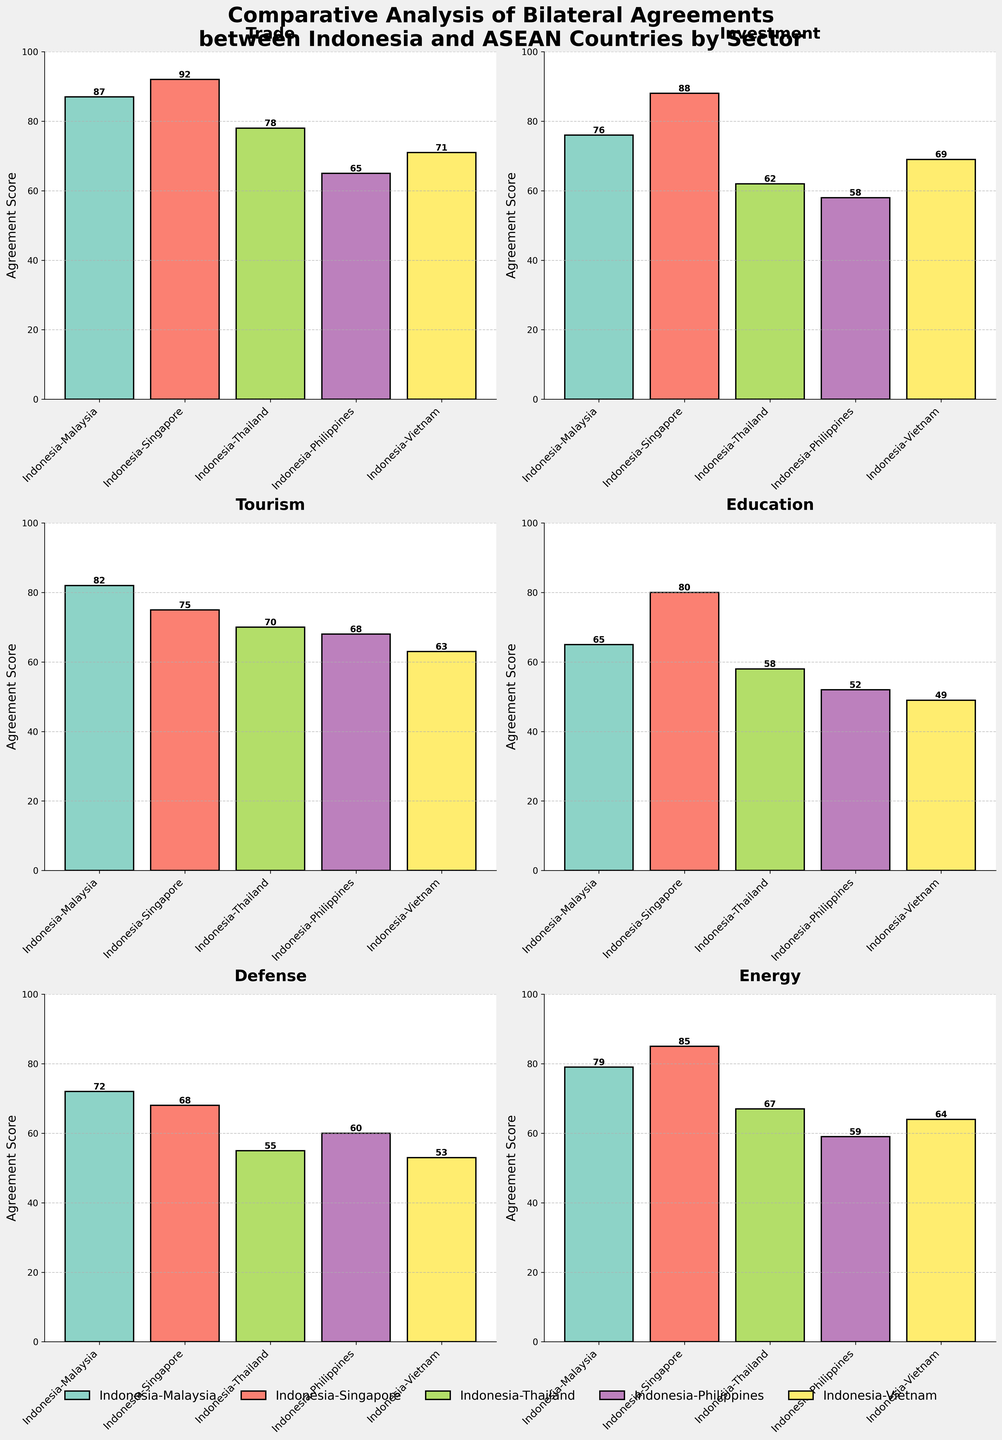Which sector has the highest agreement score between Indonesia and Vietnam? By examining the heights of the bars corresponding to Indonesia-Vietnam in each subplot, the Agriculture sector has the tallest bar indicating the highest agreement score.
Answer: Agriculture Which country, between Malaysia and Singapore, has the higher agreement score with Indonesia in the Energy sector? By comparing the heights of the bars in the Energy sector subplot for both Indonesia-Malaysia and Indonesia-Singapore, the bar for Singapore is taller.
Answer: Singapore Which sector has the lowest agreement score between Indonesia and the Philippines? By looking at the heights of the bars in Indonesia-Philippines across all subplots, the Education sector has the shortest bar.
Answer: Education Which sector shows the smallest difference in agreement scores between Indonesia and Malaysia versus Indonesia and Thailand? By calculating the absolute differences in bar heights for each sector, the Culture sector shows the smallest difference, with scores of 83 for Indonesia-Malaysia and 75 for Indonesia-Thailand, a difference of 8.
Answer: Culture What is the average agreement score between Indonesia and Singapore across all sectors? Add up all the agreement scores for Indonesia-Singapore and divide by the number of sectors (15). The total agreement score is 1,134 (92+88+75+80+68+85+89+60+58+72+77+86+74+71+82) and the average is 1,134/15 ≈ 75.6.
Answer: 75.6 Which sector has the highest variation in agreement scores between the five countries? By visually inspecting the differences in bar heights for all sectors, the Fisheries sector has the highest variation, with scores of (85, 58, 76, 72, and 79) respectively.
Answer: Fisheries What is the total agreement score in the Trade sector across all five countries? Sum the agreement scores for the Trade sector from Indonesia-Malaysia, Indonesia-Singapore, Indonesia-Thailand, Indonesia-Philippines, and Indonesia-Vietnam. (87 + 92 + 78 + 65 + 71) = 393.
Answer: 393 Which country has the lowest agreement score with Indonesia in the Technology sector? By examining the bar heights in the Technology sector subplot, the Philippines has the shortest bar.
Answer: Philippines In which sectors does Indonesia have a higher agreement score with Malaysia compared to Singapore? By comparing the bar heights in the relevant subplots, Indonesia has higher agreement scores with Malaysia than Singapore in the sectors of Fisheries, Culture, Health, and Maritime.
Answer: Fisheries, Culture, Health, and Maritime Which two sectors have the closest agreement scores between Indonesia and the Philippines? By calculating the absolute difference between the agreement scores for Indonesia-Philippines in each sector, the sectors with the smallest differences are Tourism (68) and Labor (70), a difference of 2.
Answer: Tourism and Labor 